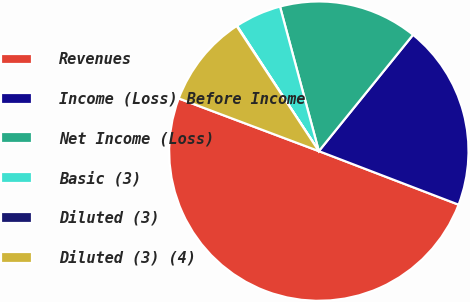<chart> <loc_0><loc_0><loc_500><loc_500><pie_chart><fcel>Revenues<fcel>Income (Loss) Before Income<fcel>Net Income (Loss)<fcel>Basic (3)<fcel>Diluted (3)<fcel>Diluted (3) (4)<nl><fcel>49.9%<fcel>19.99%<fcel>15.01%<fcel>5.03%<fcel>0.05%<fcel>10.02%<nl></chart> 